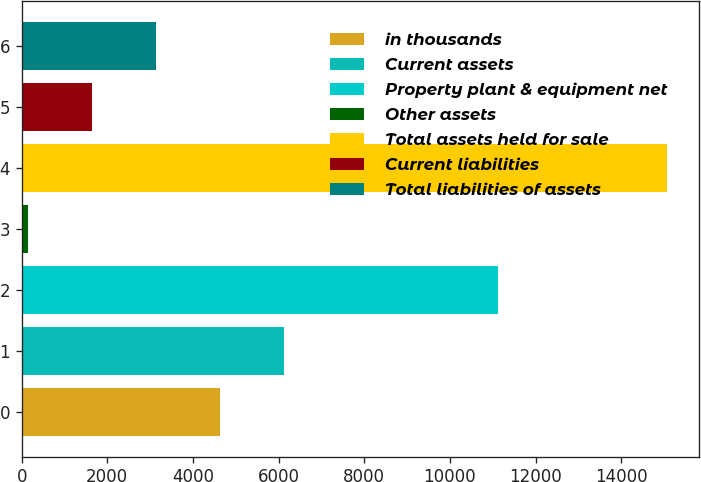Convert chart. <chart><loc_0><loc_0><loc_500><loc_500><bar_chart><fcel>in thousands<fcel>Current assets<fcel>Property plant & equipment net<fcel>Other assets<fcel>Total assets held for sale<fcel>Current liabilities<fcel>Total liabilities of assets<nl><fcel>4630.8<fcel>6122.4<fcel>11117<fcel>156<fcel>15072<fcel>1647.6<fcel>3139.2<nl></chart> 